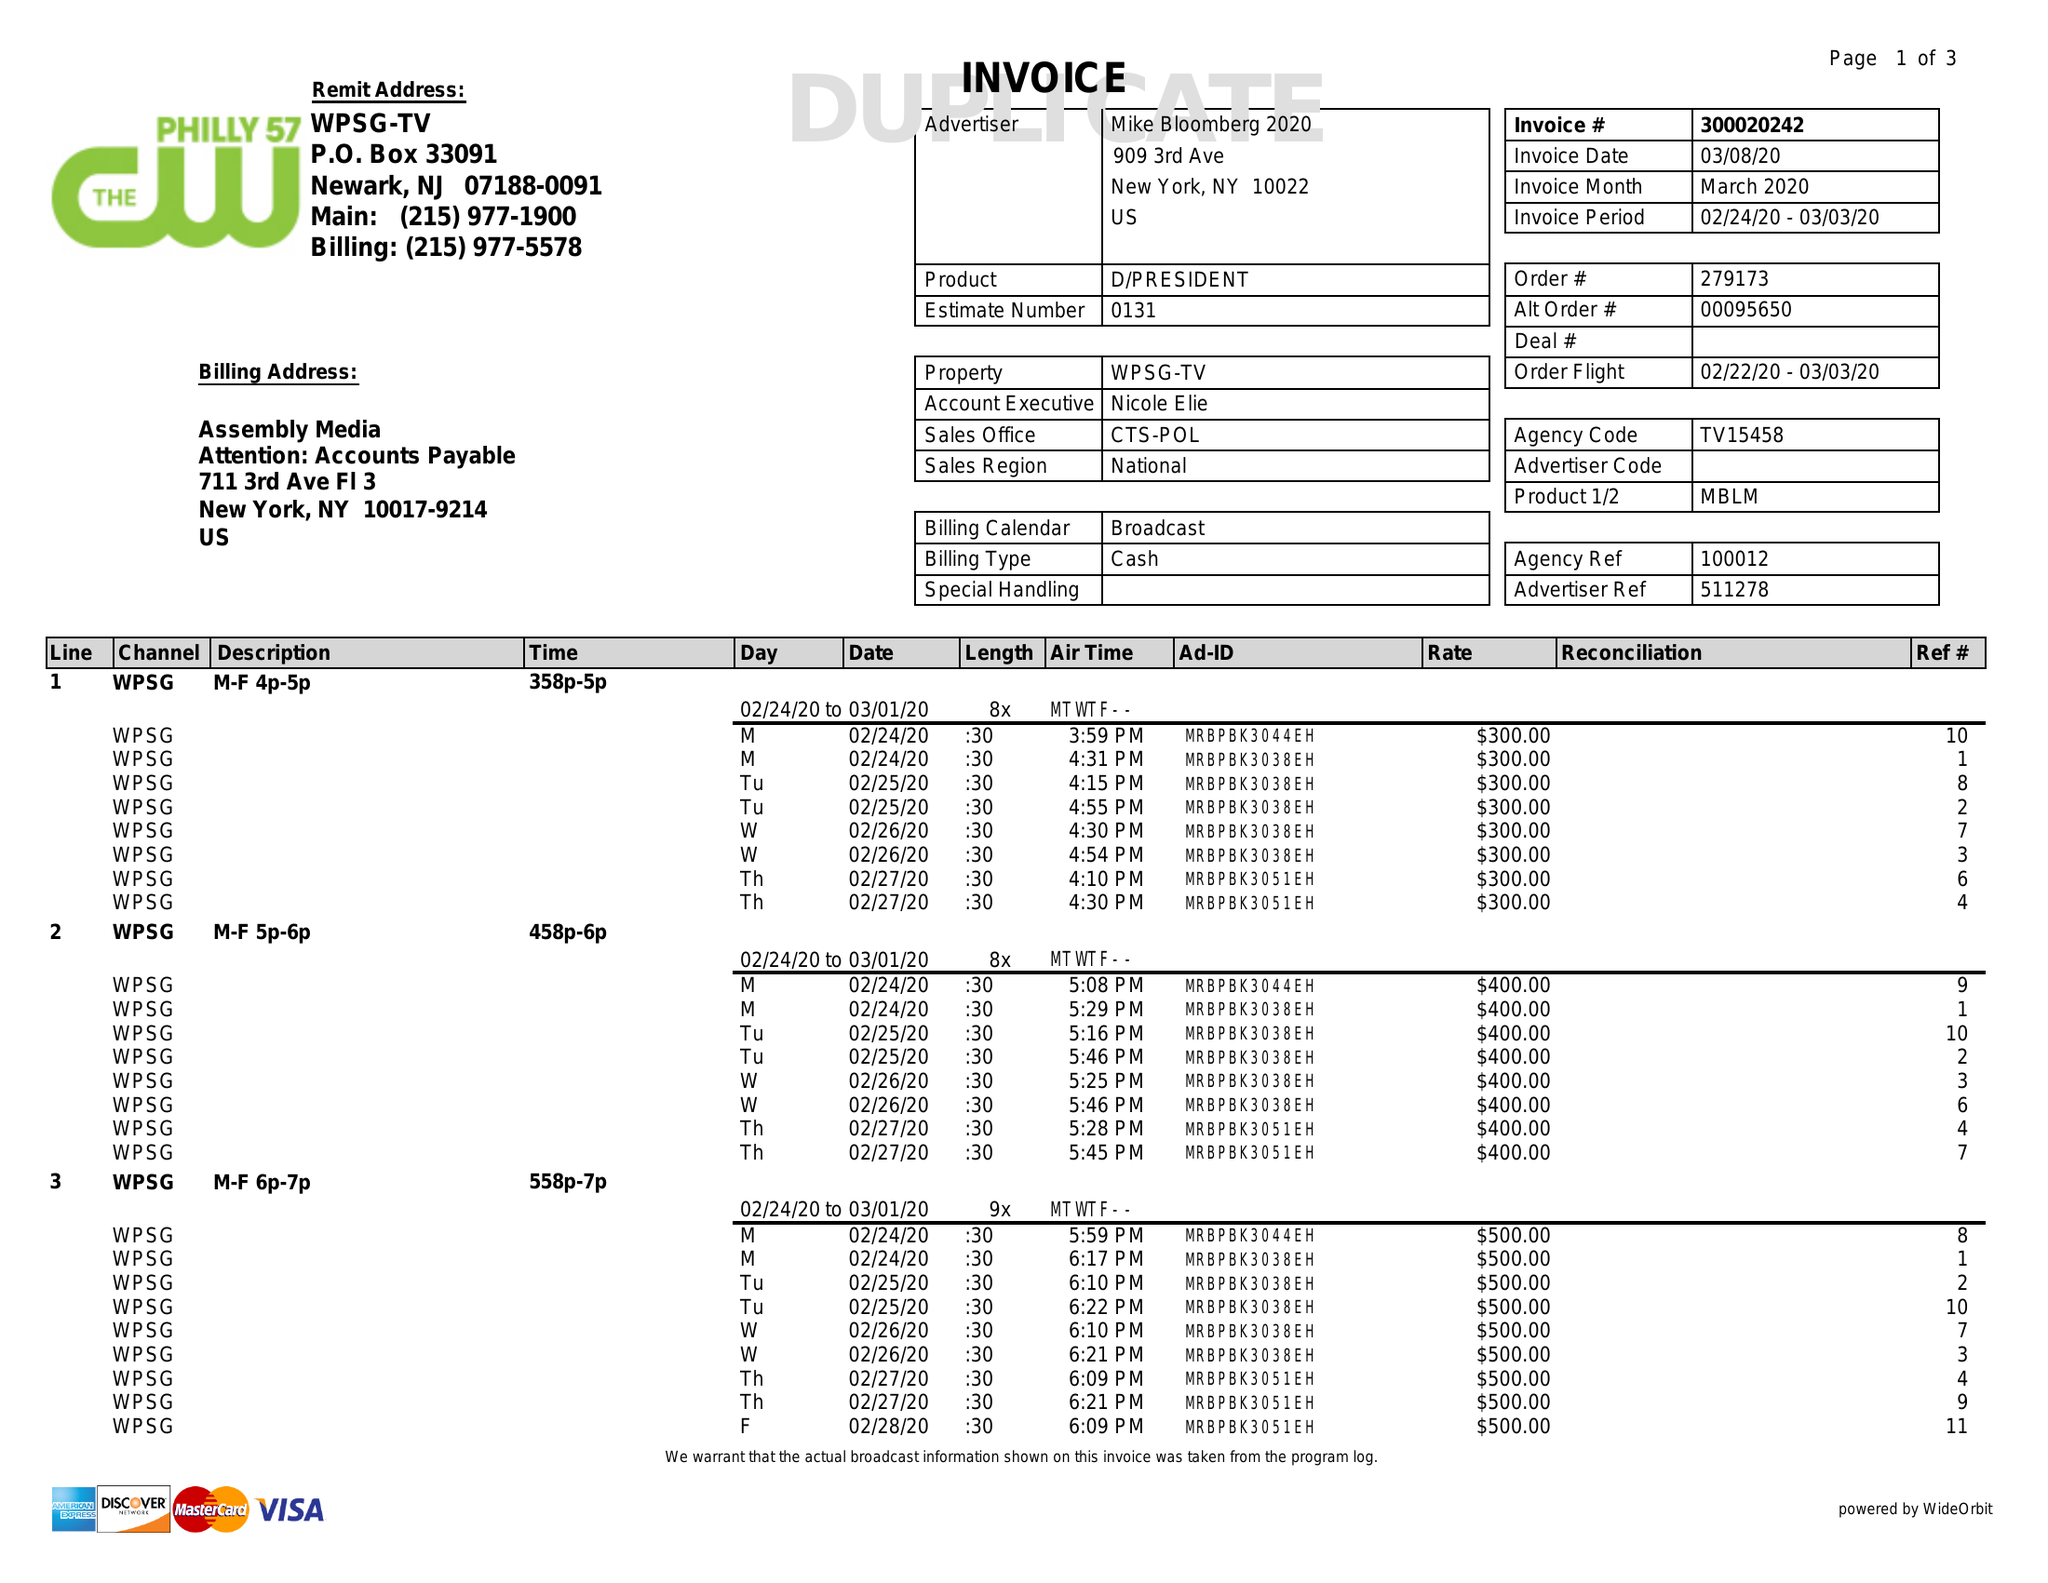What is the value for the gross_amount?
Answer the question using a single word or phrase. 27800.00 